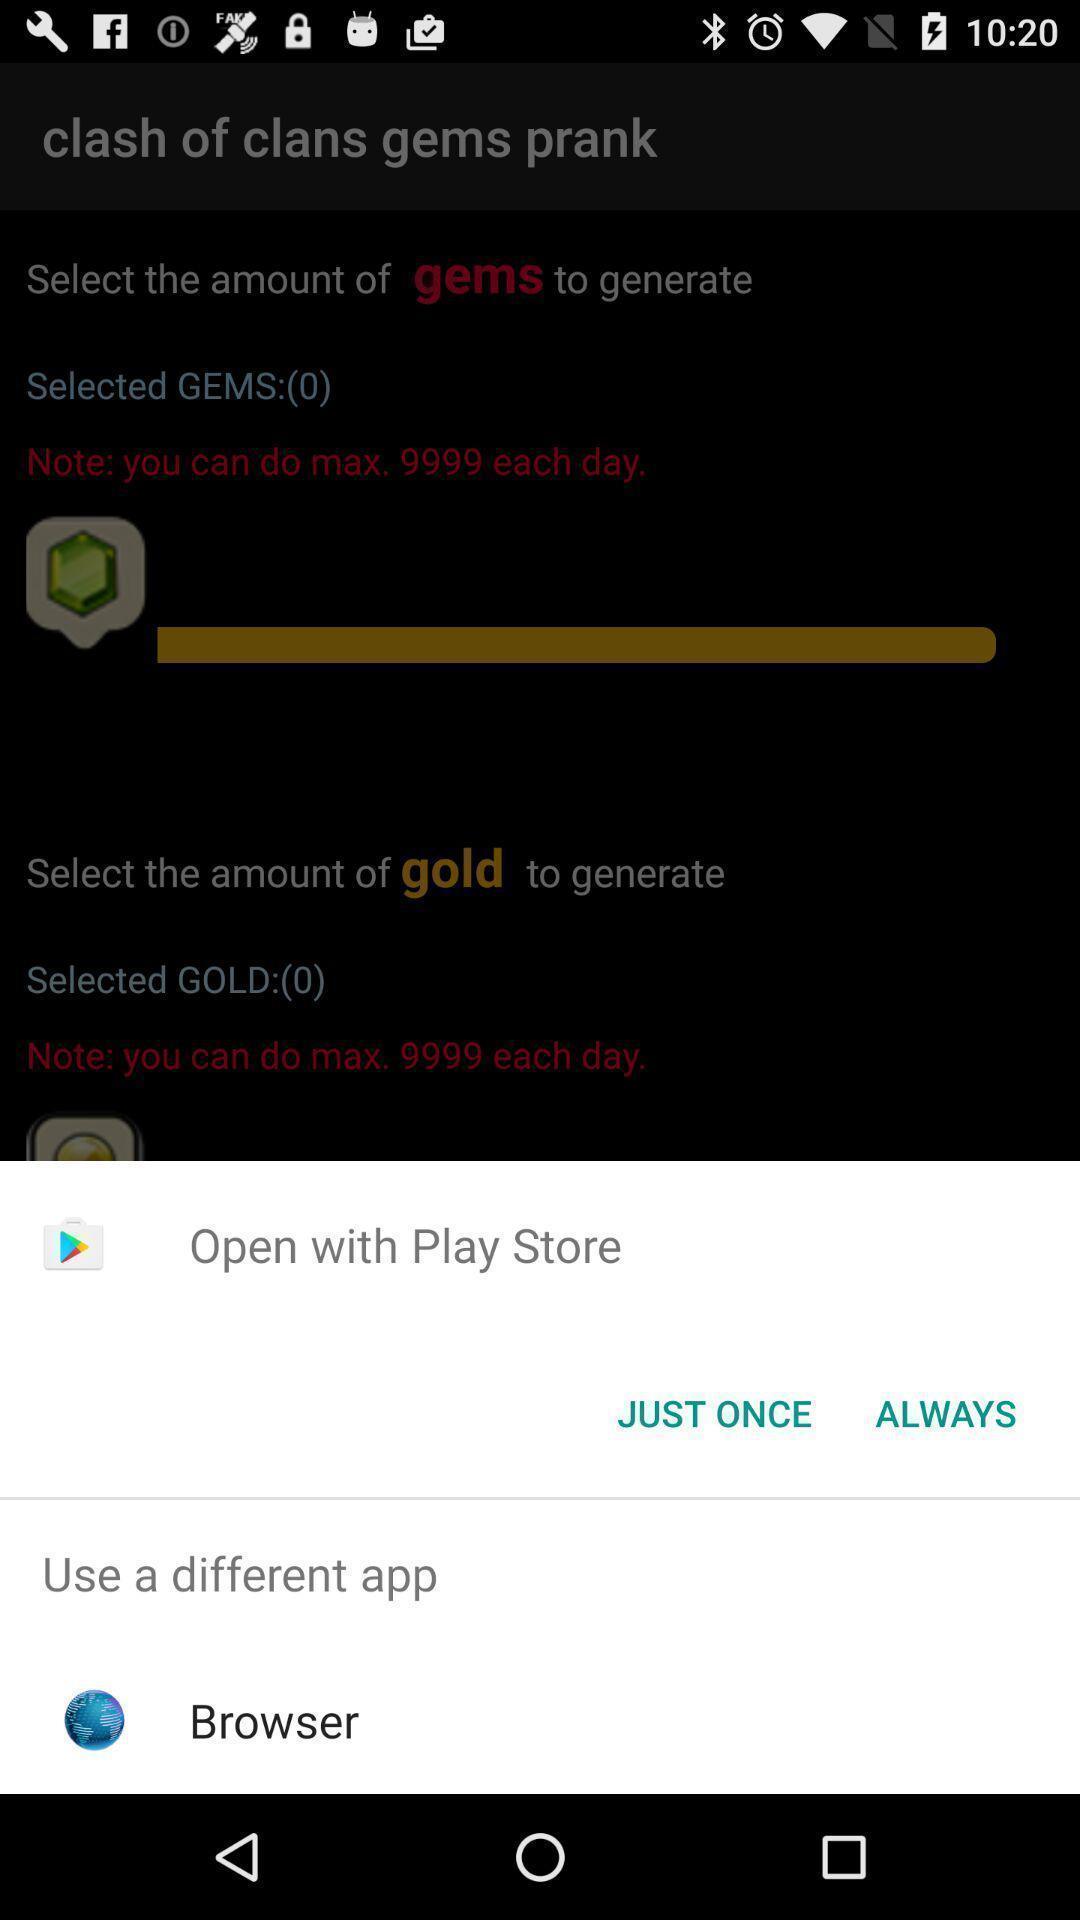What is the overall content of this screenshot? Popup showing about different apps. 